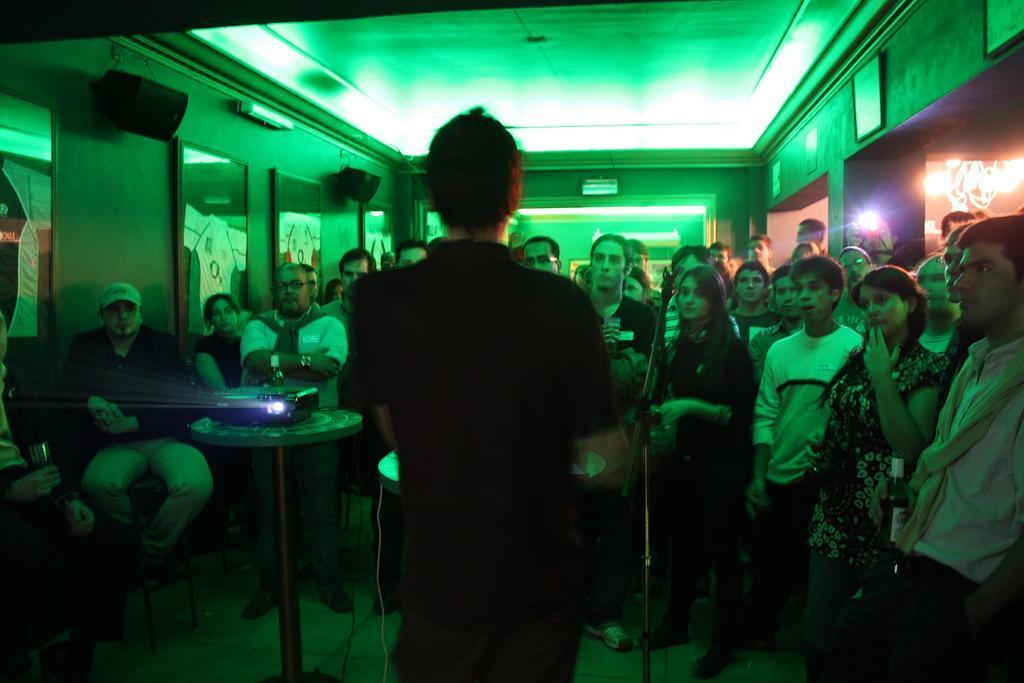In one or two sentences, can you explain what this image depicts? In this image we can group of people standing on the floor. In the foreground we can see a stand, projector placed on a stand. In the background, we can see group of photo frame, speakers on the wall and some lights. 